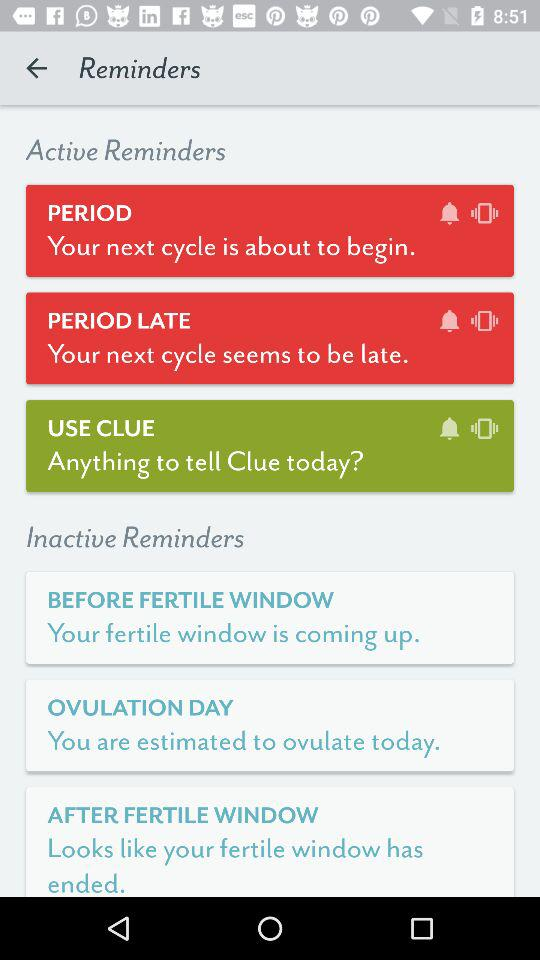How many reminders are active?
Answer the question using a single word or phrase. 3 